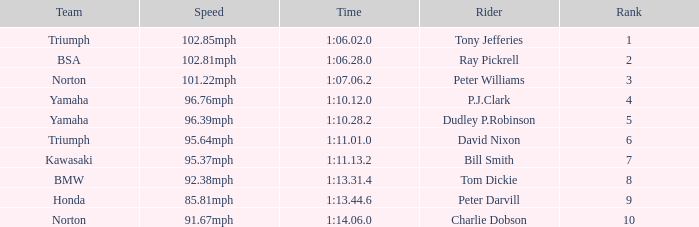How many Ranks have ray pickrell as a Rider? 1.0. 